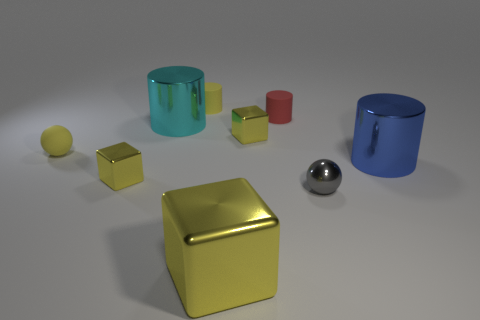Subtract all cylinders. How many objects are left? 5 Subtract all small brown metal things. Subtract all metal cylinders. How many objects are left? 7 Add 6 tiny spheres. How many tiny spheres are left? 8 Add 7 small red objects. How many small red objects exist? 8 Subtract 0 blue spheres. How many objects are left? 9 